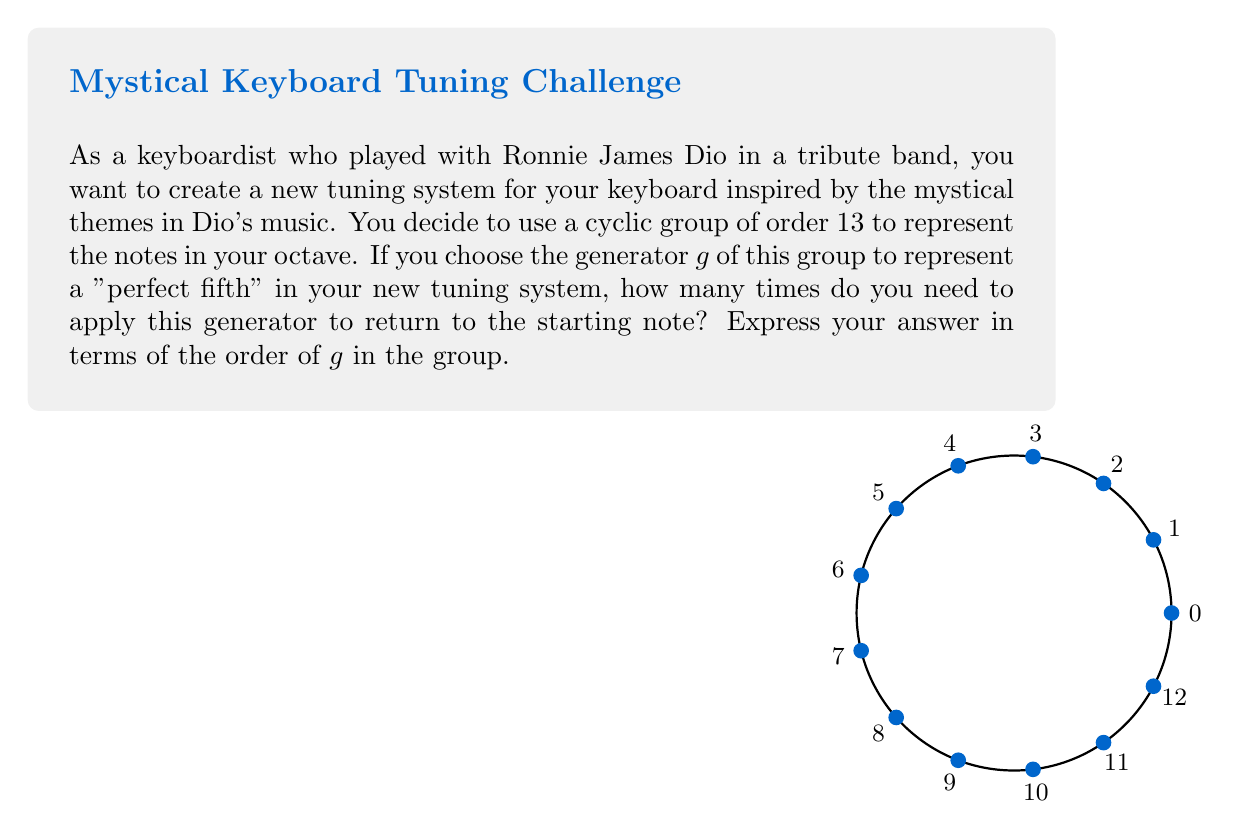Give your solution to this math problem. Let's approach this step-by-step:

1) We are working with a cyclic group of order 13, which we can represent as $\mathbb{Z}_{13}$ under addition modulo 13.

2) In this group, each element can be represented as $0, 1, 2, ..., 12$.

3) The generator $g$ represents a "perfect fifth" in this system. In traditional Western music, a perfect fifth is 7 semitones above the starting note. So, we can represent $g$ as 7 in our group.

4) To find how many times we need to apply $g$ to return to the starting note, we need to find the smallest positive integer $n$ such that:

   $$ng \equiv 0 \pmod{13}$$

5) This is equivalent to solving:

   $$7n \equiv 0 \pmod{13}$$

6) The solution to this congruence is the order of $g$ in the group, which we can denote as $|g|$.

7) To solve this, we can use the fact that in a group of order $m$, for any element $a$:

   $$a^m \equiv 1 \pmod{m}$$

8) In our case, this means:

   $$7^{13} \equiv 1 \pmod{13}$$

9) However, we want the smallest positive $n$ that satisfies our congruence. We can find this by testing powers of 7:

   $7^1 \equiv 7 \pmod{13}$
   $7^2 \equiv 10 \pmod{13}$
   $7^3 \equiv 5 \pmod{13}$
   $7^4 \equiv 9 \pmod{13}$
   $7^5 \equiv 11 \pmod{13}$
   $7^6 \equiv 12 \pmod{13}$
   $7^7 \equiv 6 \pmod{13}$
   $7^8 \equiv 3 \pmod{13}$
   $7^9 \equiv 8 \pmod{13}$
   $7^{10} \equiv 4 \pmod{13}$
   $7^{11} \equiv 2 \pmod{13}$
   $7^{12} \equiv 1 \pmod{13}$

10) We see that $7^{12} \equiv 1 \pmod{13}$, which means $7^{12} \equiv 0 \pmod{13}$ in additive notation.

Therefore, the order of $g$ in this group is 12.
Answer: $|g| = 12$ 